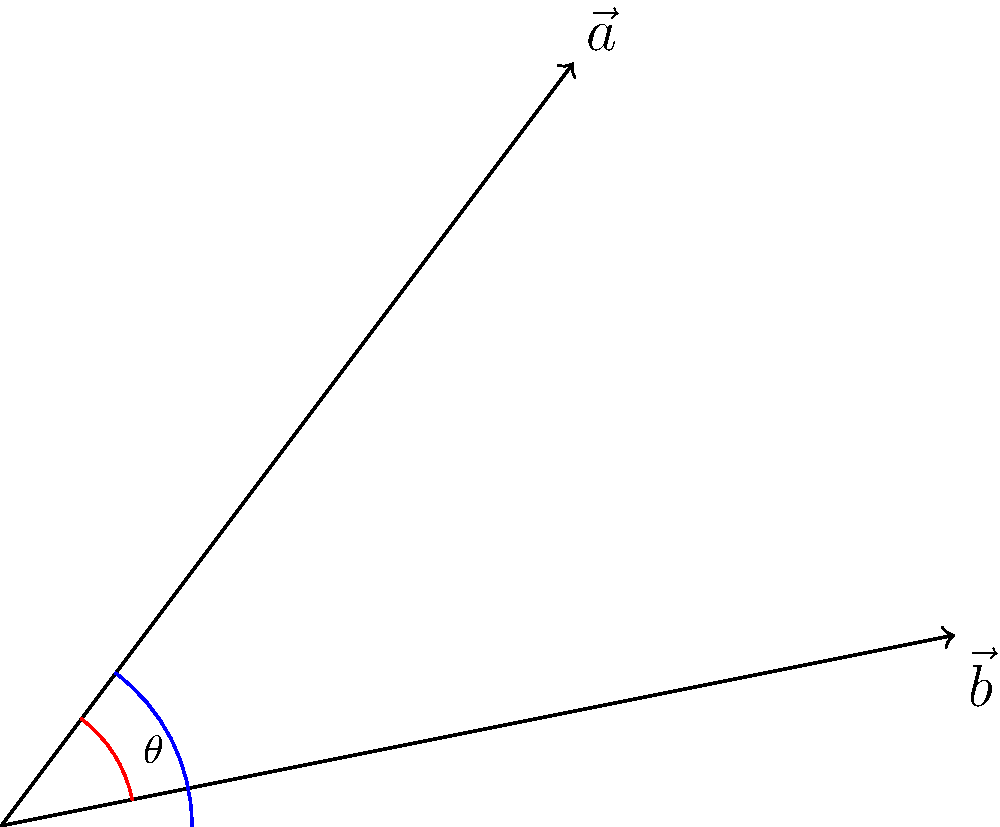In the realm of social movements, two conflicting ideologies can be represented by vectors $\vec{a}$ and $\vec{b}$. If $\vec{a} = 3\hat{i} + 4\hat{j}$ and $\vec{b} = 5\hat{i} + \hat{j}$, what is the angle $\theta$ between these ideologies? Remember, as Martin Luther King Jr. said, "The arc of the moral universe is long, but it bends toward justice." How might this angle reflect the challenge in reconciling different perspectives? To find the angle between two vectors, we can use the dot product formula:

1) The dot product formula: $\cos \theta = \frac{\vec{a} \cdot \vec{b}}{|\vec{a}||\vec{b}|}$

2) Calculate the dot product:
   $\vec{a} \cdot \vec{b} = (3)(5) + (4)(1) = 15 + 4 = 19$

3) Calculate the magnitudes:
   $|\vec{a}| = \sqrt{3^2 + 4^2} = \sqrt{9 + 16} = \sqrt{25} = 5$
   $|\vec{b}| = \sqrt{5^2 + 1^2} = \sqrt{25 + 1} = \sqrt{26}$

4) Substitute into the formula:
   $\cos \theta = \frac{19}{5\sqrt{26}}$

5) Take the inverse cosine (arccos) of both sides:
   $\theta = \arccos(\frac{19}{5\sqrt{26}})$

6) Calculate the result:
   $\theta \approx 0.5805$ radians or $33.27°$

This angle represents the divergence between the two ideologies. A smaller angle would indicate more closely aligned perspectives, while a larger angle would suggest more conflicting viewpoints.
Answer: $\theta = \arccos(\frac{19}{5\sqrt{26}}) \approx 33.27°$ 